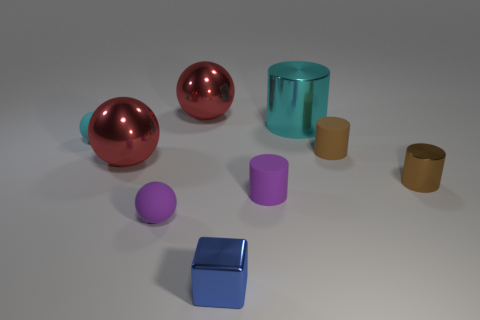Are there any tiny purple cylinders that are in front of the small sphere that is right of the tiny cyan matte thing?
Give a very brief answer. No. Does the small shiny block have the same color as the tiny shiny object that is right of the blue block?
Provide a succinct answer. No. Are there any yellow things made of the same material as the tiny cyan object?
Your answer should be compact. No. How many tiny purple objects are there?
Offer a terse response. 2. There is a small sphere in front of the small purple object that is right of the blue metallic thing; what is it made of?
Offer a very short reply. Rubber. The tiny object that is the same material as the tiny block is what color?
Your response must be concise. Brown. There is a tiny rubber object that is the same color as the big cylinder; what is its shape?
Ensure brevity in your answer.  Sphere. Do the shiny cylinder that is behind the small cyan rubber sphere and the object on the right side of the tiny brown matte cylinder have the same size?
Provide a short and direct response. No. What number of cubes are either large cyan things or large metal things?
Your response must be concise. 0. Does the purple object to the right of the tiny blue cube have the same material as the big cylinder?
Your response must be concise. No. 